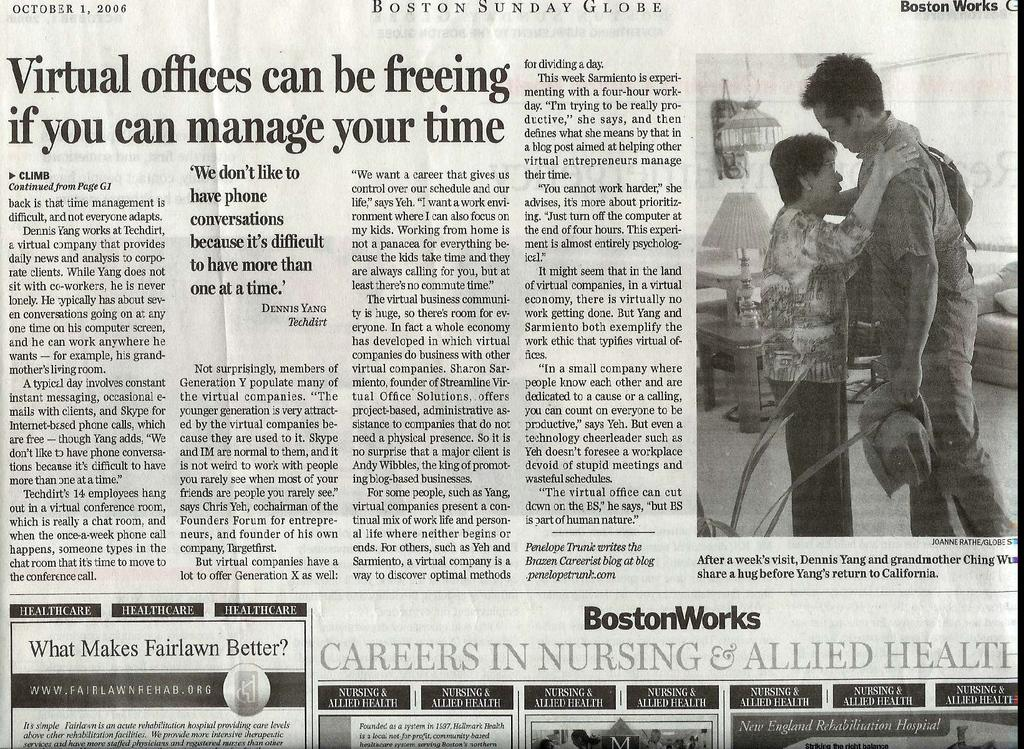How many people are present in the image? There is a man and a woman in the image, making a total of two people. What are the man and woman doing in the image? The man and woman are standing on the floor. What type of furniture can be seen in the image? There is a lamp and a sofa in the image. Is there any text visible in the image? Yes, there is text visible in the image. How many balls are being juggled by the turkey in the image? There is no turkey or balls present in the image. What is the value of the item being discussed in the image? There is no discussion or item with a value present in the image. 